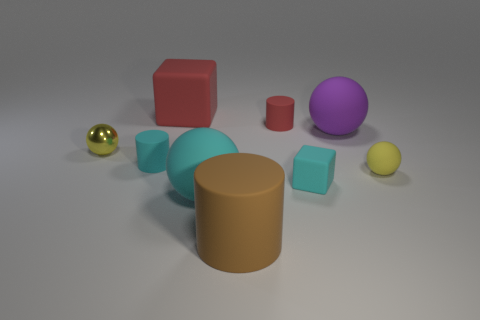Does the big purple ball have the same material as the large red thing?
Ensure brevity in your answer.  Yes. How many things are in front of the rubber ball in front of the small yellow matte thing?
Make the answer very short. 1. Are there any cyan things that have the same shape as the big red matte thing?
Keep it short and to the point. Yes. There is a yellow thing left of the large cyan matte object; is its shape the same as the yellow object in front of the metal object?
Keep it short and to the point. Yes. What is the shape of the large matte object that is both behind the small rubber sphere and on the left side of the big purple sphere?
Make the answer very short. Cube. Are there any cyan matte cylinders that have the same size as the cyan matte block?
Ensure brevity in your answer.  Yes. Do the big block and the tiny matte cylinder right of the brown matte cylinder have the same color?
Your answer should be compact. Yes. What is the material of the small cyan cube?
Offer a terse response. Rubber. The cube that is on the left side of the brown matte cylinder is what color?
Offer a very short reply. Red. What number of tiny rubber spheres have the same color as the large block?
Provide a succinct answer. 0. 